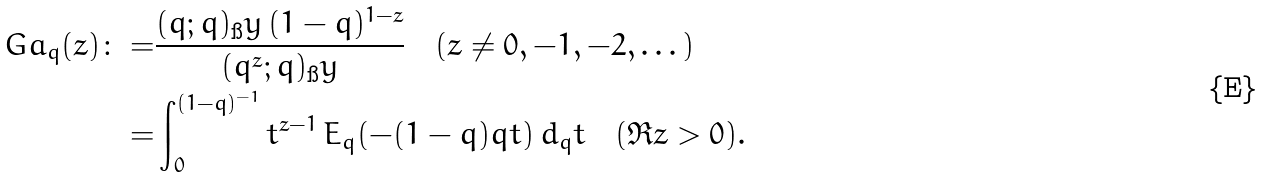Convert formula to latex. <formula><loc_0><loc_0><loc_500><loc_500>\ G a _ { q } ( z ) \colon = & \frac { ( q ; q ) _ { \i } y \, ( 1 - q ) ^ { 1 - z } } { ( q ^ { z } ; q ) _ { \i } y } \quad ( z \ne 0 , - 1 , - 2 , \dots ) \\ = & \int _ { 0 } ^ { ( 1 - q ) ^ { - 1 } } t ^ { z - 1 } \, E _ { q } ( - ( 1 - q ) q t ) \, d _ { q } t \quad ( \Re z > 0 ) .</formula> 